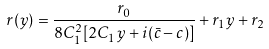<formula> <loc_0><loc_0><loc_500><loc_500>r ( y ) = \frac { r _ { 0 } } { 8 C _ { 1 } ^ { 2 } [ 2 C _ { 1 } y + i ( \bar { c } - c ) ] } + r _ { 1 } y + r _ { 2 }</formula> 